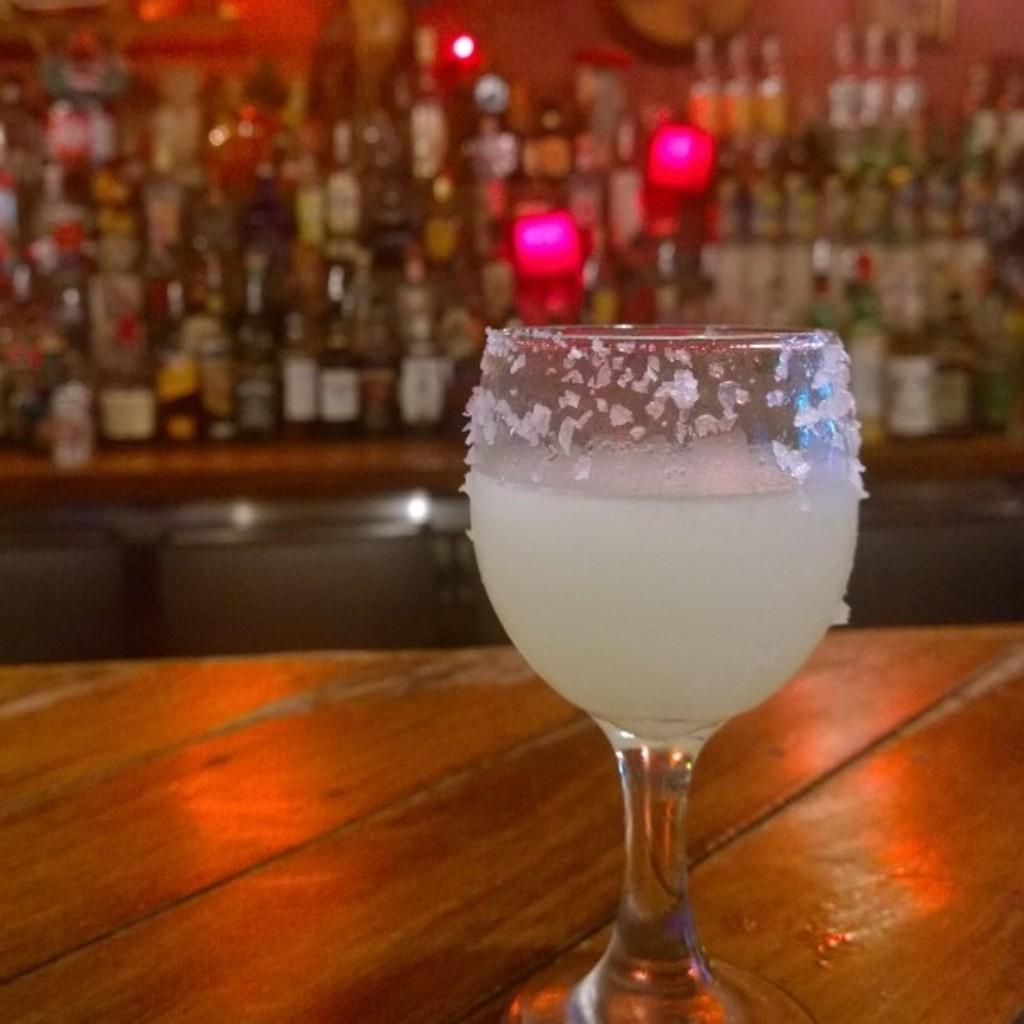What is contained in the glass that is visible in the image? There is a glass with liquid in the image. Where is the glass placed in the image? The glass is on a wooden surface in the image. What can be seen in the background of the image? There are bottles arranged in a rack in the background of the image. How many fish are swimming in the glass in the image? There are no fish present in the image; it contains a glass with liquid. 